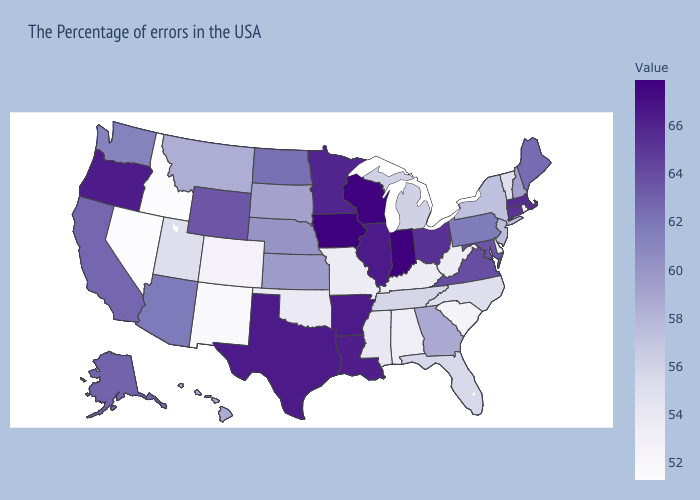Does Connecticut have the lowest value in the USA?
Give a very brief answer. No. Which states have the lowest value in the USA?
Short answer required. Idaho, Nevada. Among the states that border New Jersey , which have the lowest value?
Short answer required. Delaware. Which states hav the highest value in the West?
Give a very brief answer. Oregon. Which states have the highest value in the USA?
Answer briefly. Indiana, Iowa. Does Iowa have the highest value in the USA?
Give a very brief answer. Yes. Which states have the highest value in the USA?
Answer briefly. Indiana, Iowa. Among the states that border Massachusetts , does Rhode Island have the lowest value?
Answer briefly. Yes. 